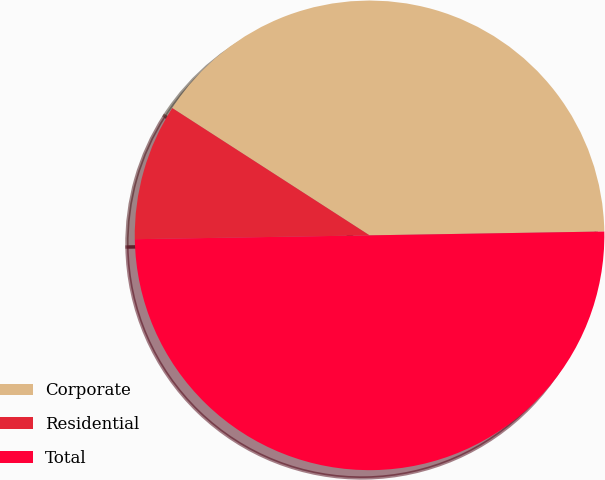Convert chart. <chart><loc_0><loc_0><loc_500><loc_500><pie_chart><fcel>Corporate<fcel>Residential<fcel>Total<nl><fcel>40.62%<fcel>9.38%<fcel>50.0%<nl></chart> 